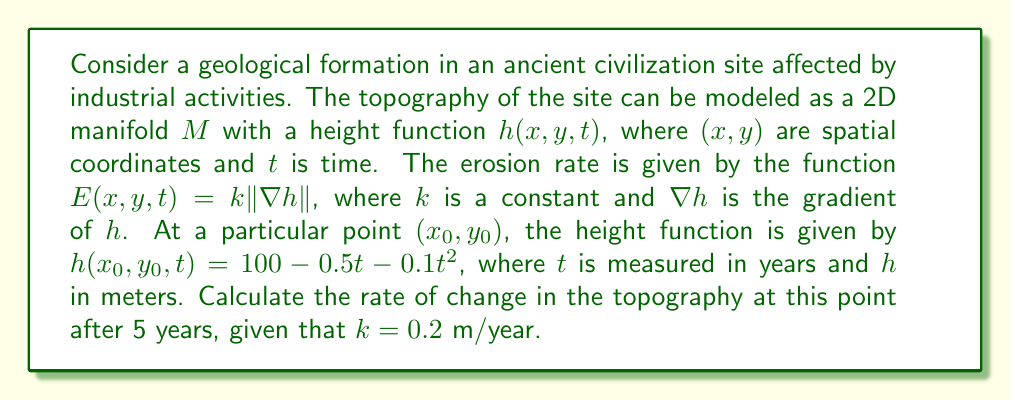Help me with this question. To solve this problem, we need to follow these steps:

1) First, we need to find the gradient of $h$ at the point $(x_0, y_0)$. Since we're only given the function of $h$ with respect to $t$ at this point, we only need to consider the partial derivative with respect to $t$:

   $$\frac{\partial h}{\partial t} = -0.5 - 0.2t$$

2) At $t = 5$ years:

   $$\frac{\partial h}{\partial t}\bigg|_{t=5} = -0.5 - 0.2(5) = -1.5\text{ m/year}$$

3) The magnitude of the gradient at this point is simply the absolute value of this partial derivative:

   $$\|\nabla h\| = |-1.5| = 1.5\text{ m/year}$$

4) Now we can calculate the erosion rate using the given formula:

   $$E(x_0, y_0, 5) = k \|\nabla h\| = 0.2 \cdot 1.5 = 0.3\text{ m/year}$$

5) The rate of change in topography is the negative of the erosion rate (as erosion decreases height):

   $$\frac{\partial h}{\partial t} = -E = -0.3\text{ m/year}$$

This means that at the point $(x_0, y_0)$ after 5 years, the topography is changing at a rate of 0.3 meters per year, decreasing in height.
Answer: The rate of change in topography at the point $(x_0, y_0)$ after 5 years is $-0.3\text{ m/year}$. 